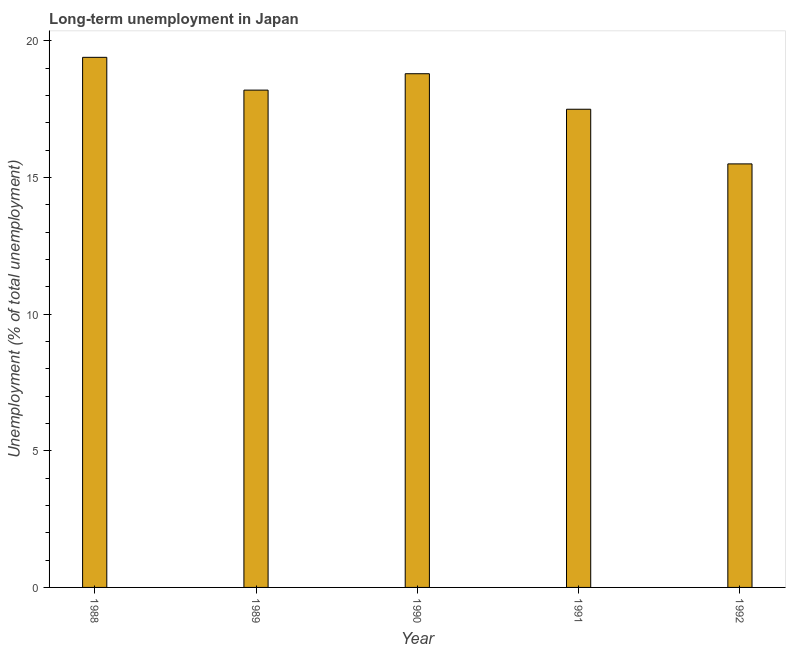Does the graph contain any zero values?
Offer a very short reply. No. What is the title of the graph?
Your answer should be compact. Long-term unemployment in Japan. What is the label or title of the Y-axis?
Offer a very short reply. Unemployment (% of total unemployment). What is the long-term unemployment in 1992?
Offer a very short reply. 15.5. Across all years, what is the maximum long-term unemployment?
Offer a terse response. 19.4. Across all years, what is the minimum long-term unemployment?
Your answer should be compact. 15.5. In which year was the long-term unemployment maximum?
Keep it short and to the point. 1988. In which year was the long-term unemployment minimum?
Provide a succinct answer. 1992. What is the sum of the long-term unemployment?
Keep it short and to the point. 89.4. What is the average long-term unemployment per year?
Provide a short and direct response. 17.88. What is the median long-term unemployment?
Make the answer very short. 18.2. In how many years, is the long-term unemployment greater than 2 %?
Offer a very short reply. 5. Do a majority of the years between 1992 and 1988 (inclusive) have long-term unemployment greater than 8 %?
Give a very brief answer. Yes. What is the ratio of the long-term unemployment in 1988 to that in 1991?
Your answer should be compact. 1.11. What is the difference between the highest and the lowest long-term unemployment?
Ensure brevity in your answer.  3.9. In how many years, is the long-term unemployment greater than the average long-term unemployment taken over all years?
Give a very brief answer. 3. Are all the bars in the graph horizontal?
Keep it short and to the point. No. Are the values on the major ticks of Y-axis written in scientific E-notation?
Give a very brief answer. No. What is the Unemployment (% of total unemployment) of 1988?
Make the answer very short. 19.4. What is the Unemployment (% of total unemployment) in 1989?
Offer a very short reply. 18.2. What is the Unemployment (% of total unemployment) of 1990?
Keep it short and to the point. 18.8. What is the Unemployment (% of total unemployment) of 1991?
Ensure brevity in your answer.  17.5. What is the Unemployment (% of total unemployment) in 1992?
Your answer should be compact. 15.5. What is the difference between the Unemployment (% of total unemployment) in 1988 and 1989?
Offer a very short reply. 1.2. What is the difference between the Unemployment (% of total unemployment) in 1988 and 1990?
Give a very brief answer. 0.6. What is the difference between the Unemployment (% of total unemployment) in 1989 and 1992?
Make the answer very short. 2.7. What is the difference between the Unemployment (% of total unemployment) in 1990 and 1992?
Offer a very short reply. 3.3. What is the ratio of the Unemployment (% of total unemployment) in 1988 to that in 1989?
Offer a very short reply. 1.07. What is the ratio of the Unemployment (% of total unemployment) in 1988 to that in 1990?
Make the answer very short. 1.03. What is the ratio of the Unemployment (% of total unemployment) in 1988 to that in 1991?
Provide a succinct answer. 1.11. What is the ratio of the Unemployment (% of total unemployment) in 1988 to that in 1992?
Provide a succinct answer. 1.25. What is the ratio of the Unemployment (% of total unemployment) in 1989 to that in 1990?
Your answer should be compact. 0.97. What is the ratio of the Unemployment (% of total unemployment) in 1989 to that in 1991?
Provide a short and direct response. 1.04. What is the ratio of the Unemployment (% of total unemployment) in 1989 to that in 1992?
Offer a terse response. 1.17. What is the ratio of the Unemployment (% of total unemployment) in 1990 to that in 1991?
Your response must be concise. 1.07. What is the ratio of the Unemployment (% of total unemployment) in 1990 to that in 1992?
Ensure brevity in your answer.  1.21. What is the ratio of the Unemployment (% of total unemployment) in 1991 to that in 1992?
Your response must be concise. 1.13. 